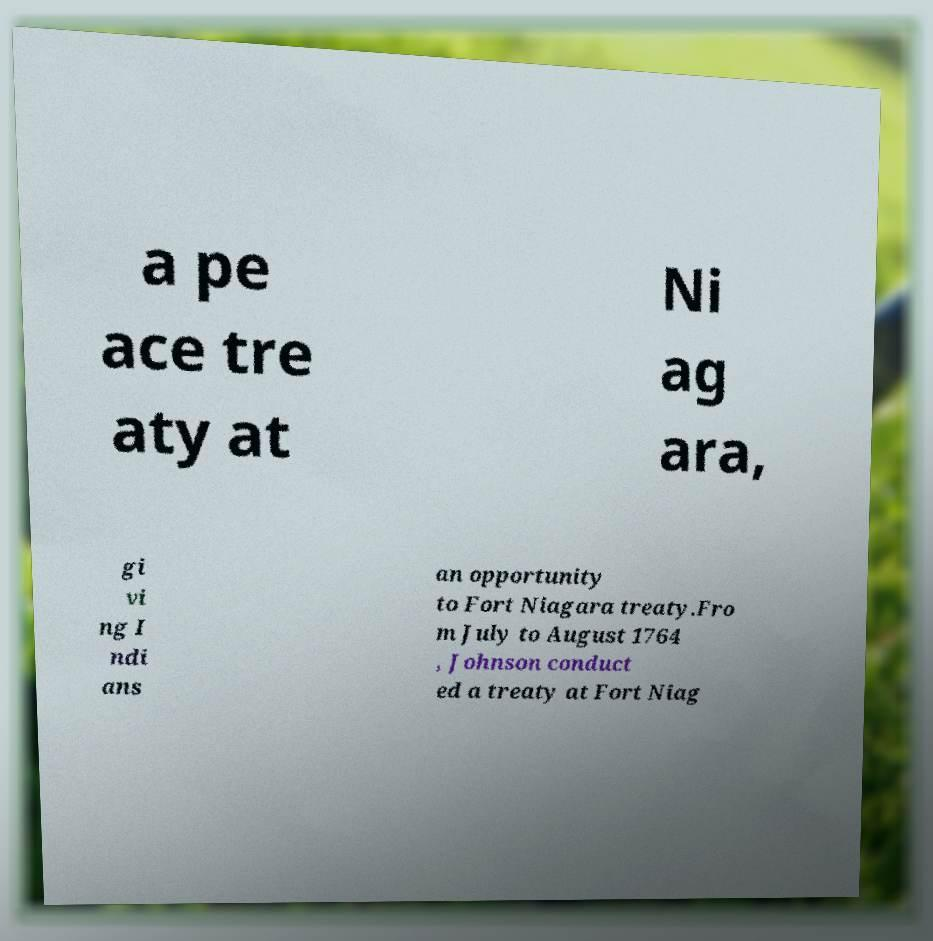Can you accurately transcribe the text from the provided image for me? a pe ace tre aty at Ni ag ara, gi vi ng I ndi ans an opportunity to Fort Niagara treaty.Fro m July to August 1764 , Johnson conduct ed a treaty at Fort Niag 